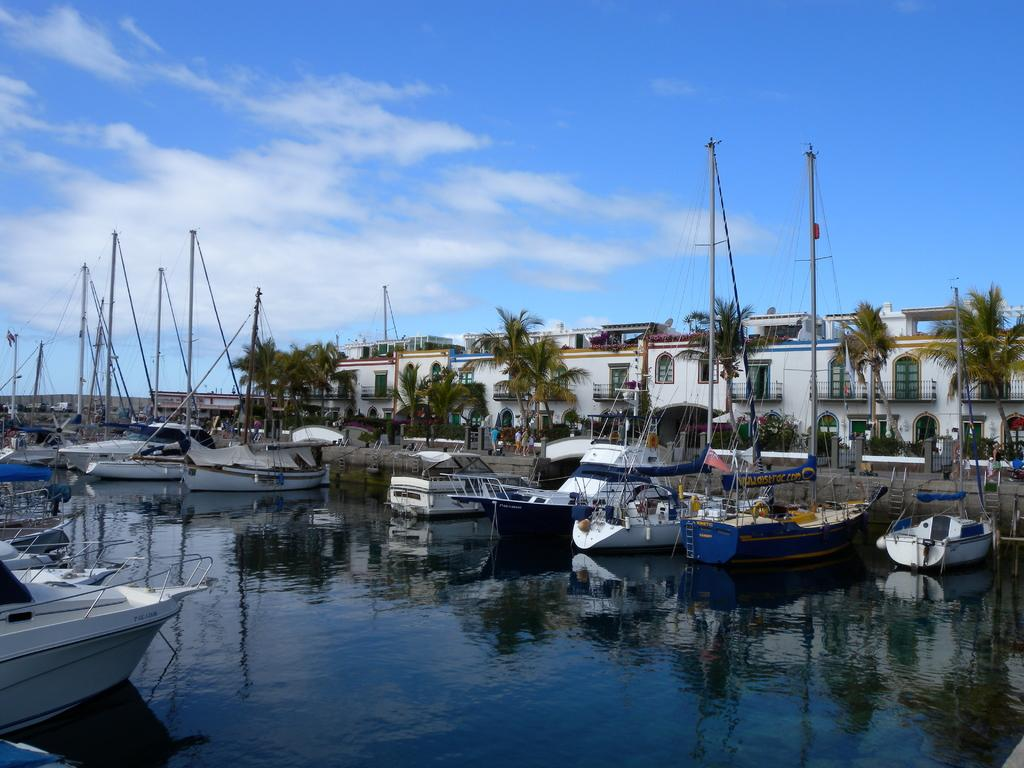What is in the water in the image? There are boats in the water in the image. What can be seen in the background of the image? There are buildings, trees, persons, and the sky visible in the background. What type of nose can be seen on the boat in the image? There are no noses present on the boats in the image, as boats do not have noses. What kind of tank is visible in the image? There is no tank present in the image; it features boats in the water and various elements in the background. 